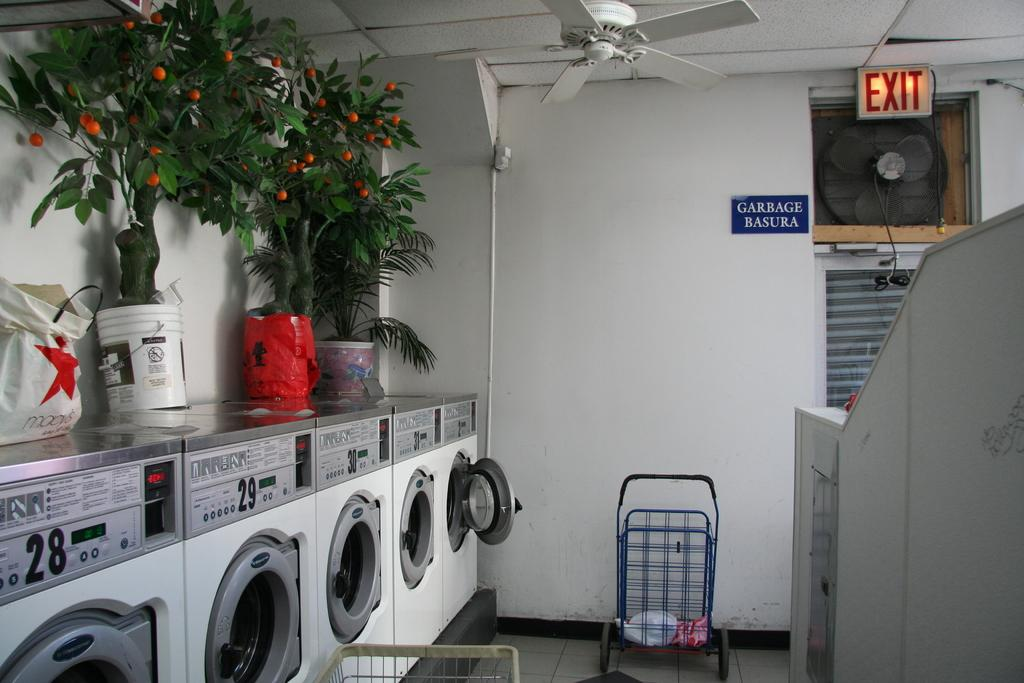<image>
Give a short and clear explanation of the subsequent image. An Exit sign is above a fan in a laundromat. 